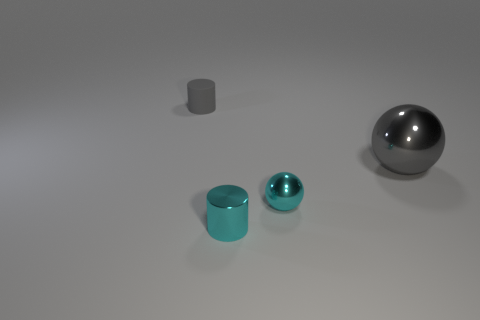How many tiny things are to the left of the cyan ball and in front of the large gray metal sphere?
Keep it short and to the point. 1. How many things are large spheres or small objects behind the big thing?
Keep it short and to the point. 2. Are there more red cubes than small metallic cylinders?
Offer a terse response. No. There is a thing behind the large gray thing; what is its shape?
Your answer should be very brief. Cylinder. How many small objects have the same shape as the large gray shiny object?
Give a very brief answer. 1. What is the size of the gray object that is right of the cylinder right of the small gray matte thing?
Your answer should be very brief. Large. What number of cyan things are small cylinders or metallic spheres?
Your response must be concise. 2. Are there fewer large spheres that are to the left of the large gray metal sphere than cyan spheres on the right side of the cyan cylinder?
Make the answer very short. Yes. There is a cyan sphere; is it the same size as the cylinder behind the small ball?
Your answer should be compact. Yes. What number of cyan metal things are the same size as the gray rubber cylinder?
Give a very brief answer. 2. 